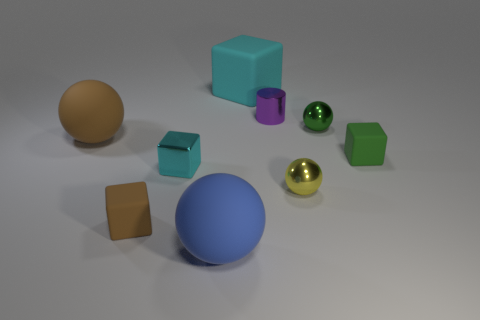What is the shape of the big thing that is the same color as the shiny block?
Ensure brevity in your answer.  Cube. There is a tiny object that is both in front of the tiny green metallic object and right of the yellow thing; what is it made of?
Offer a very short reply. Rubber. What size is the shiny block that is the same color as the large rubber cube?
Provide a short and direct response. Small. There is a tiny brown object in front of the big matte ball to the left of the large blue rubber thing; what is its material?
Your answer should be compact. Rubber. There is a matte sphere behind the metal sphere left of the small ball that is behind the green rubber thing; what size is it?
Provide a succinct answer. Large. What number of big green spheres are the same material as the purple cylinder?
Your response must be concise. 0. What is the color of the rubber object on the left side of the tiny matte block that is to the left of the small purple shiny cylinder?
Provide a short and direct response. Brown. What number of objects are green things or rubber blocks behind the brown block?
Your response must be concise. 3. Is there a large block that has the same color as the small metal block?
Offer a very short reply. Yes. How many red things are big matte balls or small cylinders?
Your response must be concise. 0. 